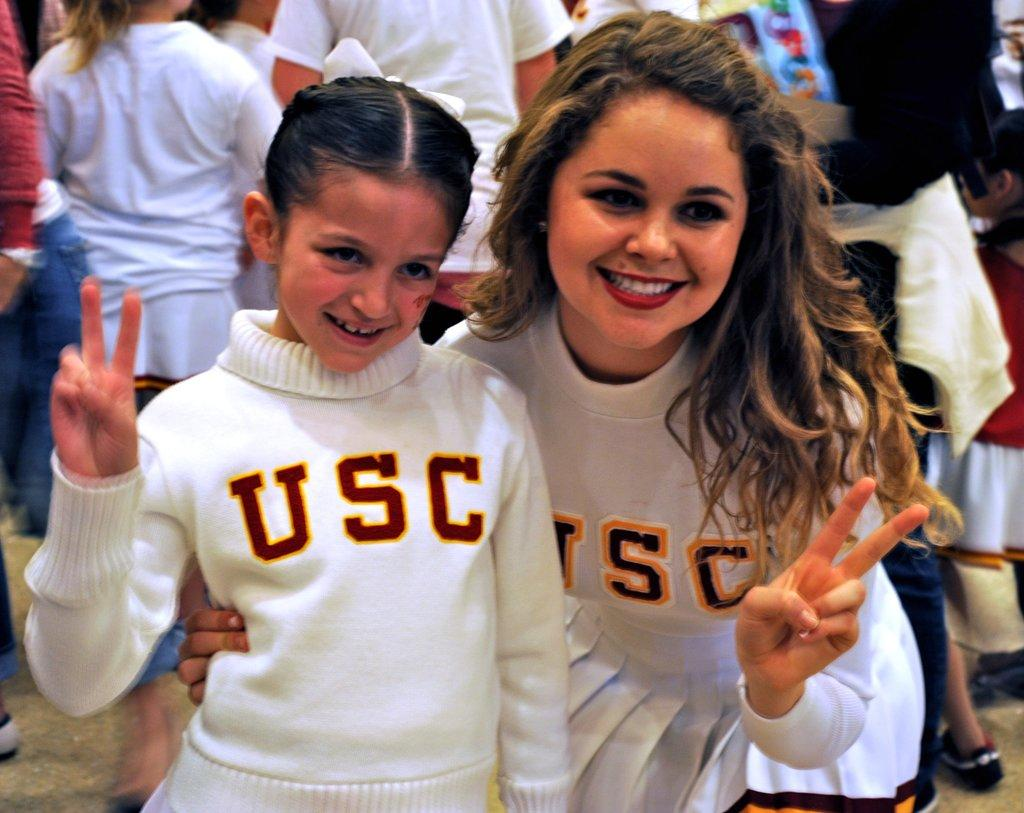Who are the main subjects in the image? There is a woman and a girl in the image. What are the woman and the girl wearing? Both the woman and the girl are wearing white t-shirts. What expressions do the woman and the girl have? Both the woman and the girl are smiling. Can you describe the people visible in the background of the image? There are persons visible in the background of the image, but no specific details are provided about them. What type of process is being judged by the woman and the girl in the image? There is no process being judged in the image. The woman and the girl are both wearing white t-shirts and smiling. 